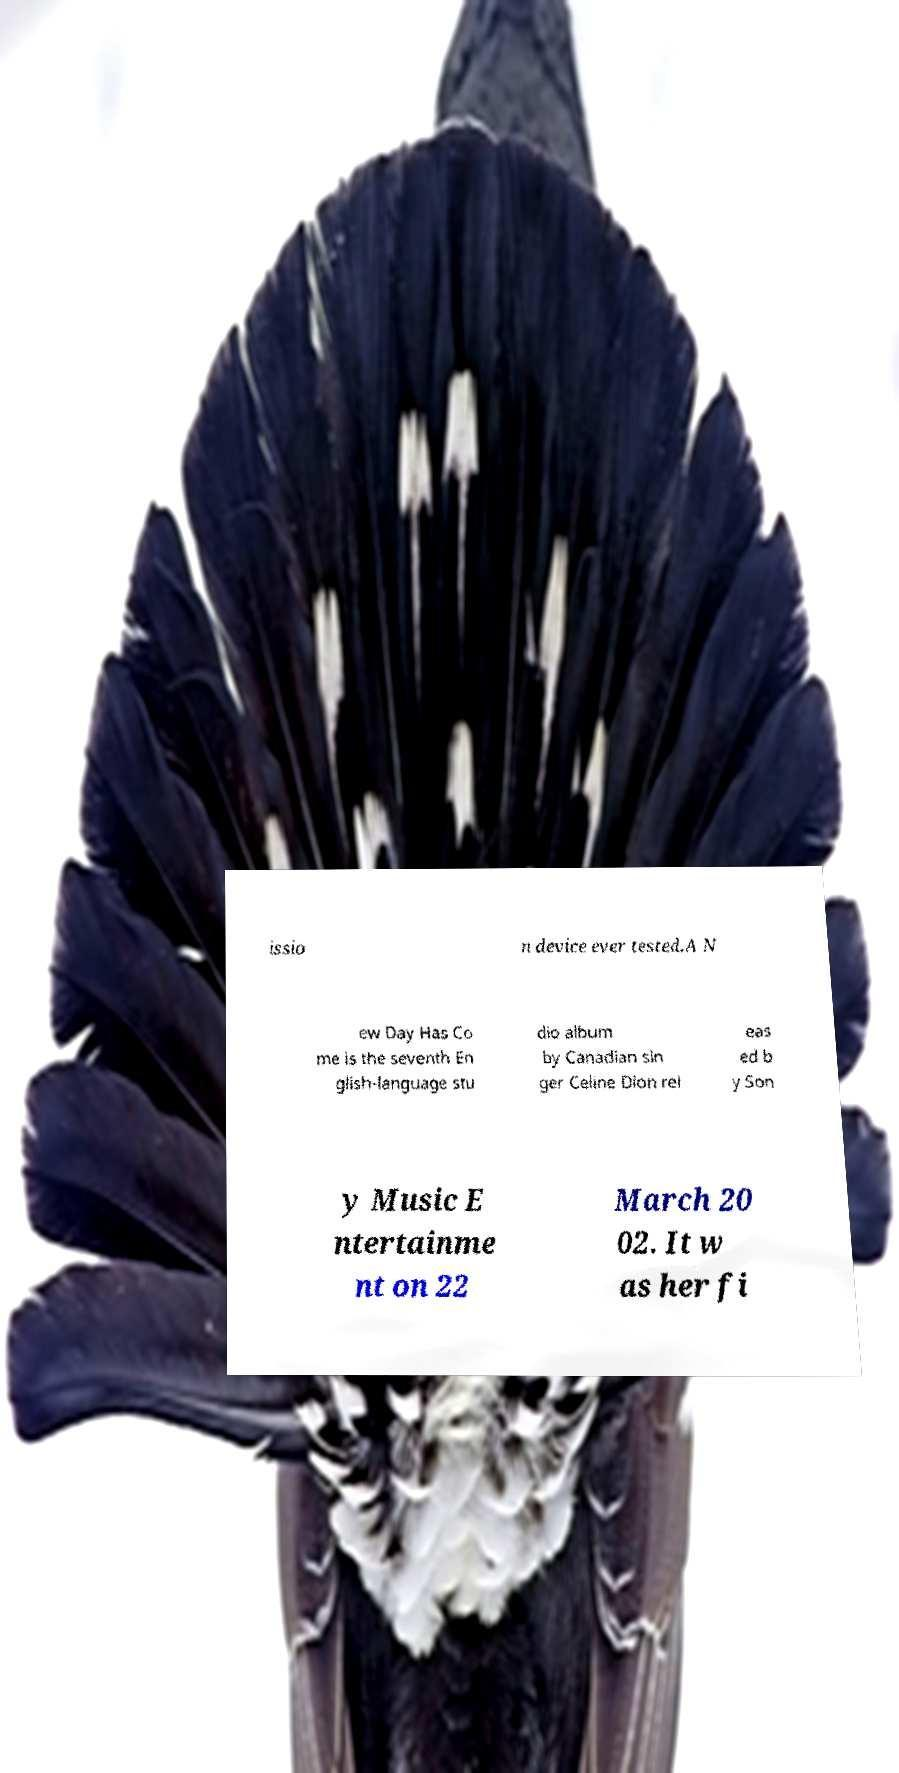There's text embedded in this image that I need extracted. Can you transcribe it verbatim? issio n device ever tested.A N ew Day Has Co me is the seventh En glish-language stu dio album by Canadian sin ger Celine Dion rel eas ed b y Son y Music E ntertainme nt on 22 March 20 02. It w as her fi 